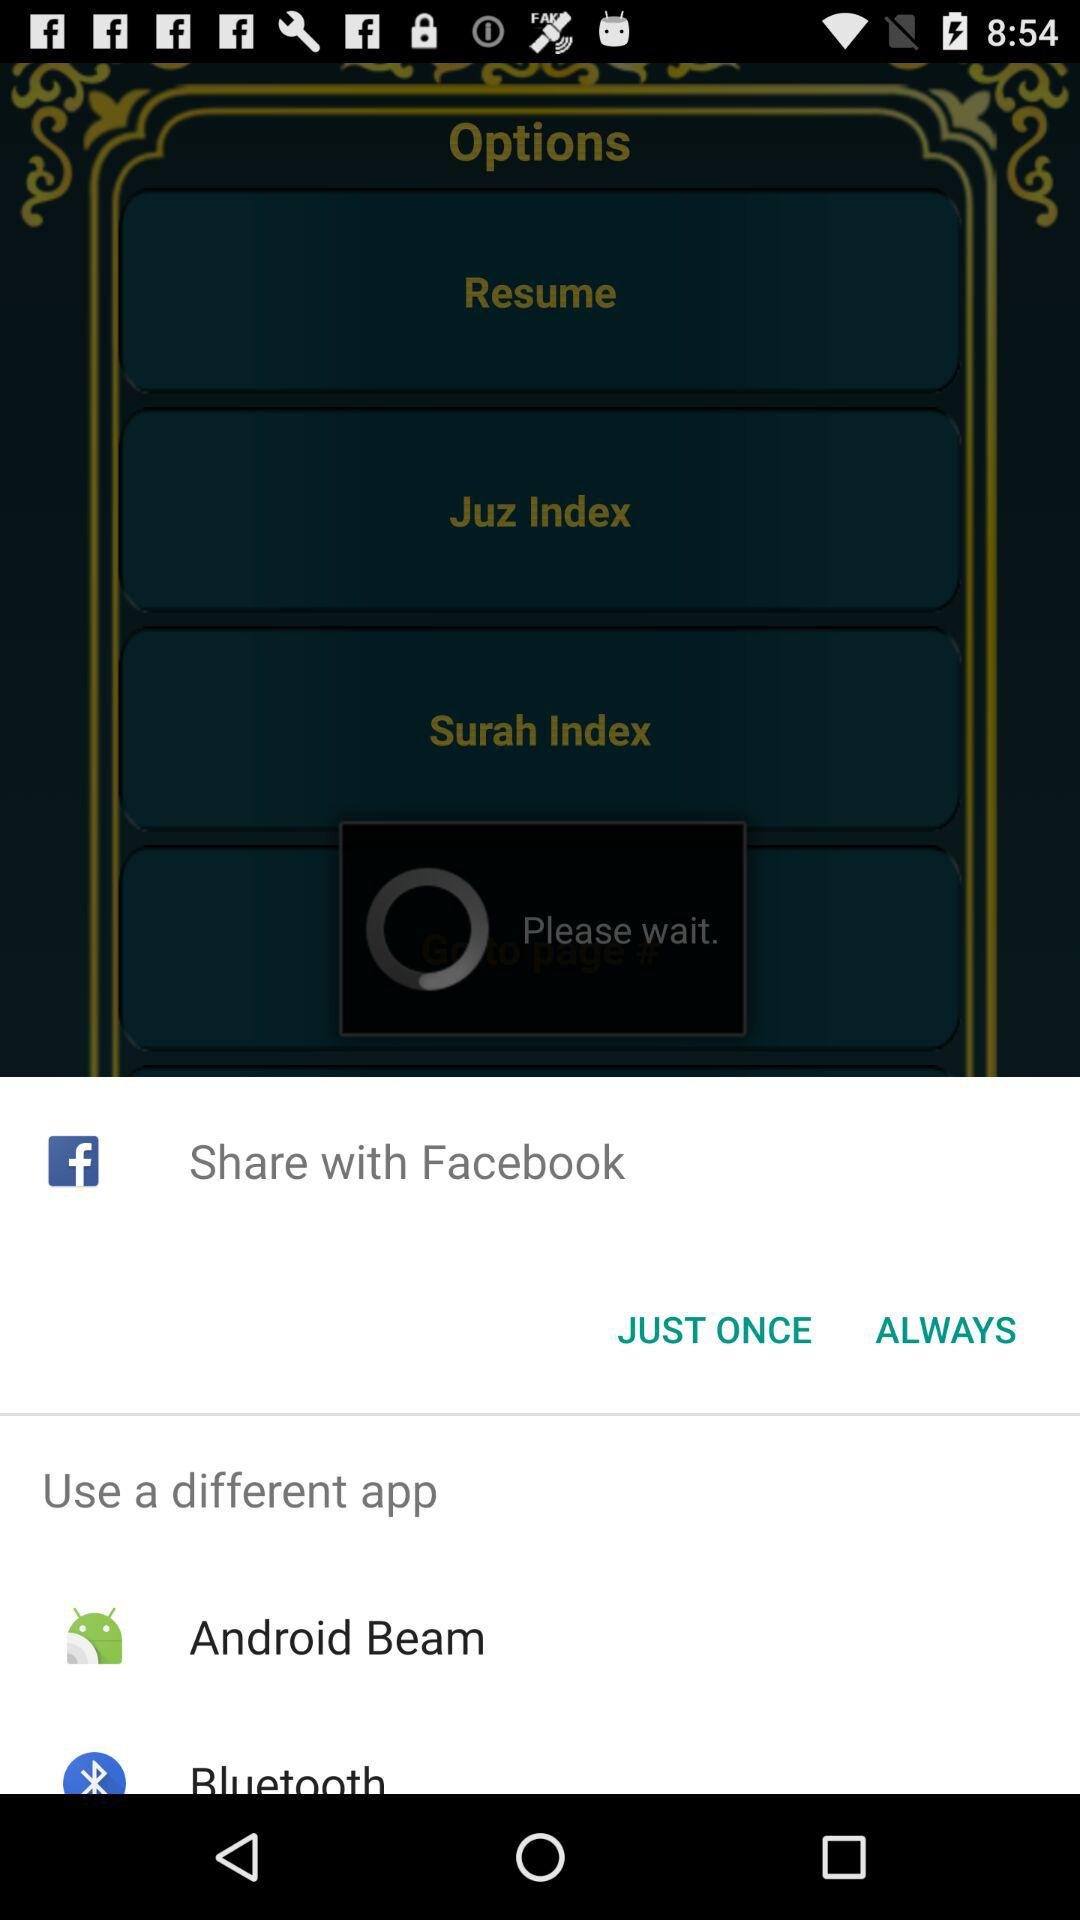Through which application can I share the content? You can share the content through "Facebook", "Android Beam" and "Bluetooth". 